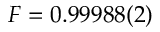<formula> <loc_0><loc_0><loc_500><loc_500>F = 0 . 9 9 9 8 8 ( 2 )</formula> 